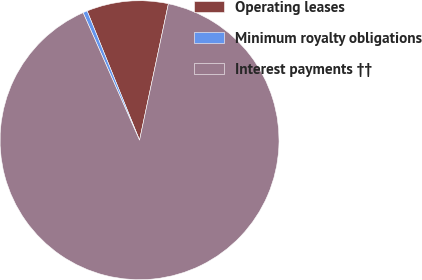Convert chart to OTSL. <chart><loc_0><loc_0><loc_500><loc_500><pie_chart><fcel>Operating leases<fcel>Minimum royalty obligations<fcel>Interest payments ††<nl><fcel>9.45%<fcel>0.5%<fcel>90.05%<nl></chart> 